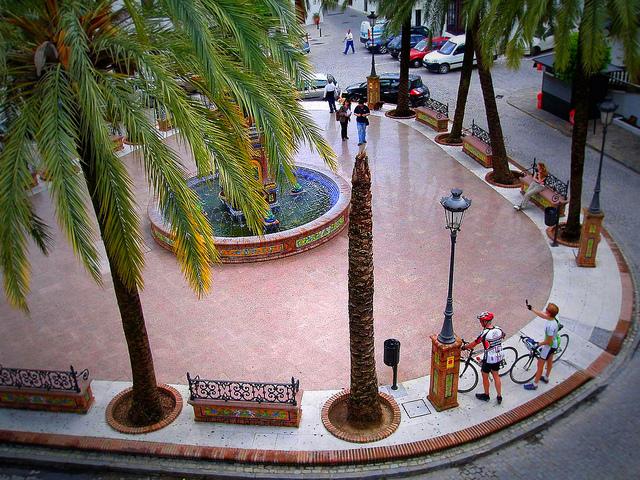Is this a museum?
Concise answer only. No. Is there a fountain in the photo?
Answer briefly. Yes. What color are the trees?
Keep it brief. Green. 